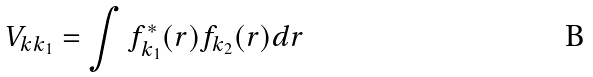<formula> <loc_0><loc_0><loc_500><loc_500>V _ { k k _ { 1 } } = \int f ^ { * } _ { k _ { 1 } } ( { r } ) f _ { k _ { 2 } } ( { r } ) d { r }</formula> 